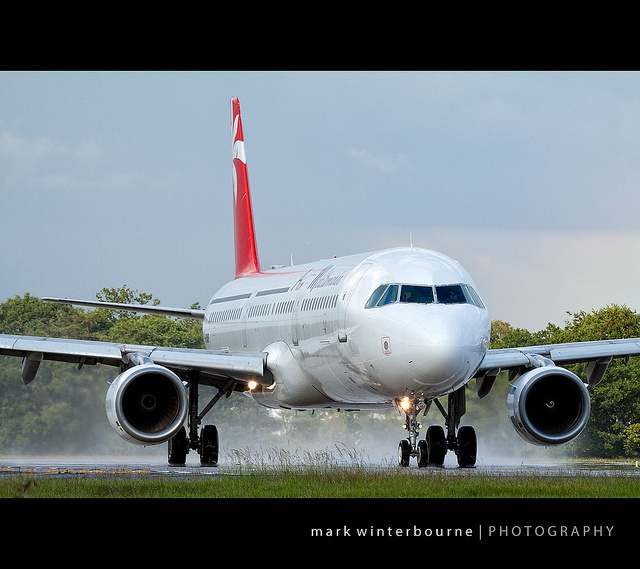Describe the objects in this image and their specific colors. I can see a airplane in black, lightgray, darkgray, and gray tones in this image. 